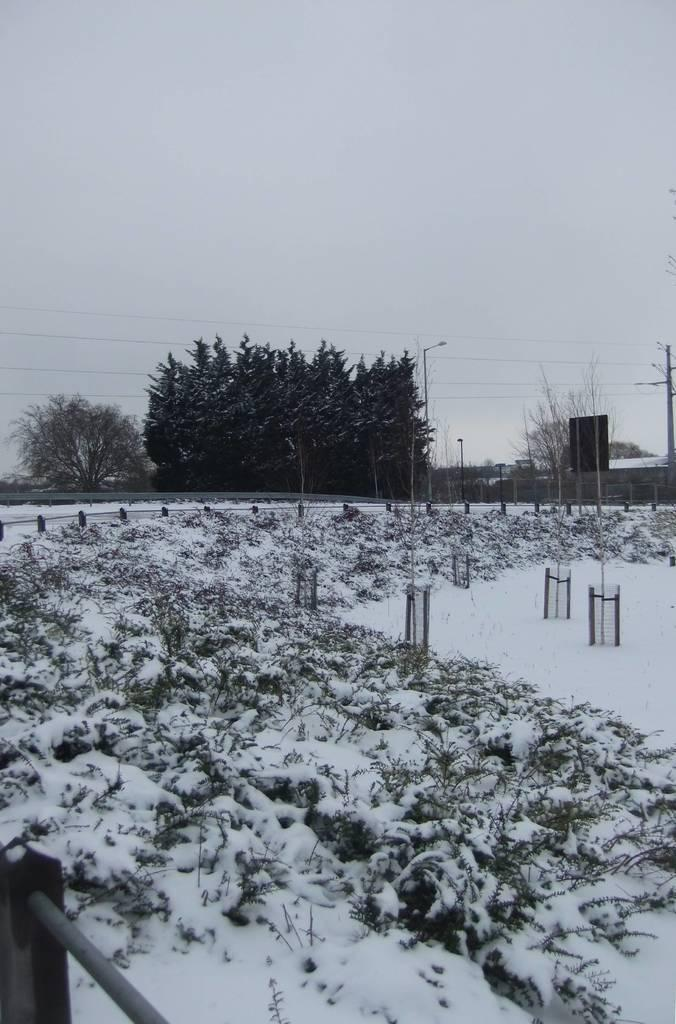What is the condition of the ground in the image? The ground is covered with snow in the image. What else is covered with snow in the image? Plants are covered with snow in the image. What structures can be seen in the image? There are nets, fencing, poles, and lights in the image. What other elements are present in the image? There are wires and trees in the image. What part of the natural environment is visible in the image? The sky is visible in the image. What type of canvas is used to create the painting in the image? There is no painting or canvas present in the image; it features a snow-covered ground and plants, along with various structures and objects. 